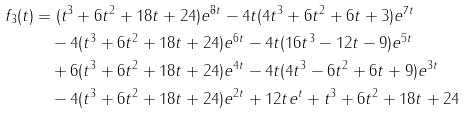Convert formula to latex. <formula><loc_0><loc_0><loc_500><loc_500>f _ { 3 } ( t ) & = ( t ^ { 3 } + 6 t ^ { 2 } + 1 8 t + 2 4 ) e ^ { 8 t } - 4 t ( 4 t ^ { 3 } + 6 t ^ { 2 } + 6 t + 3 ) e ^ { 7 t } \\ & \quad - 4 ( t ^ { 3 } + 6 t ^ { 2 } + 1 8 t + 2 4 ) e ^ { 6 t } - 4 t ( 1 6 t ^ { 3 } - 1 2 t - 9 ) e ^ { 5 t } \\ & \quad + 6 ( t ^ { 3 } + 6 t ^ { 2 } + 1 8 t + 2 4 ) e ^ { 4 t } - 4 t ( 4 t ^ { 3 } - 6 t ^ { 2 } + 6 t + 9 ) e ^ { 3 t } \\ & \quad - 4 ( t ^ { 3 } + 6 t ^ { 2 } + 1 8 t + 2 4 ) e ^ { 2 t } + 1 2 t e ^ { t } + t ^ { 3 } + 6 t ^ { 2 } + 1 8 t + 2 4</formula> 